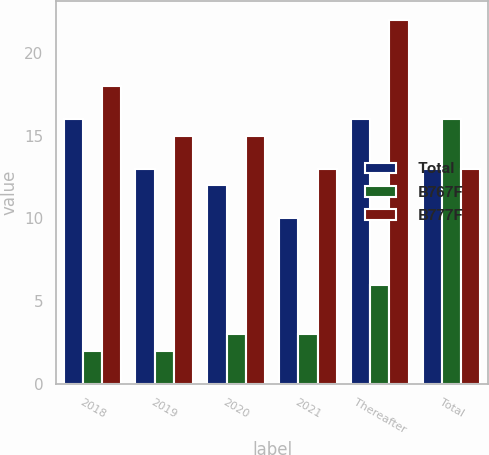<chart> <loc_0><loc_0><loc_500><loc_500><stacked_bar_chart><ecel><fcel>2018<fcel>2019<fcel>2020<fcel>2021<fcel>Thereafter<fcel>Total<nl><fcel>Total<fcel>16<fcel>13<fcel>12<fcel>10<fcel>16<fcel>13<nl><fcel>B767F<fcel>2<fcel>2<fcel>3<fcel>3<fcel>6<fcel>16<nl><fcel>B777F<fcel>18<fcel>15<fcel>15<fcel>13<fcel>22<fcel>13<nl></chart> 